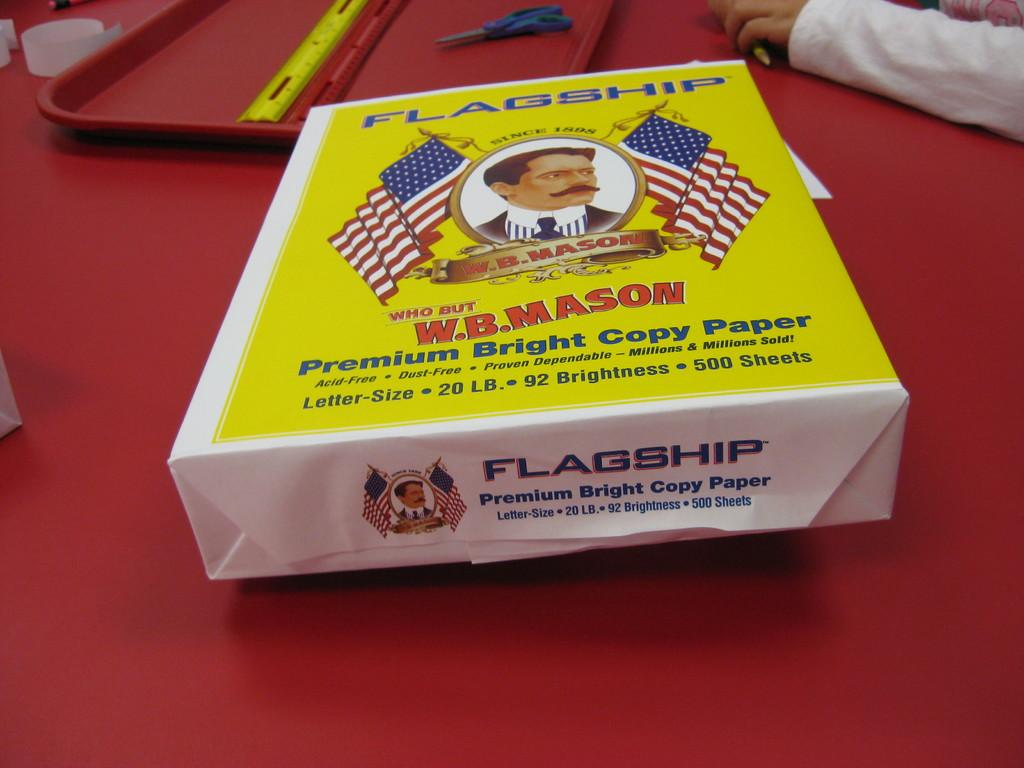<image>
Create a compact narrative representing the image presented. A ream of Flagship Premium Bright Copy Paper sits on a red table. 